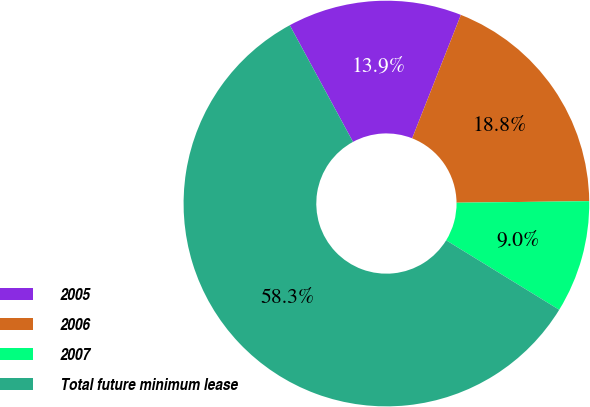Convert chart. <chart><loc_0><loc_0><loc_500><loc_500><pie_chart><fcel>2005<fcel>2006<fcel>2007<fcel>Total future minimum lease<nl><fcel>13.89%<fcel>18.83%<fcel>8.96%<fcel>58.32%<nl></chart> 